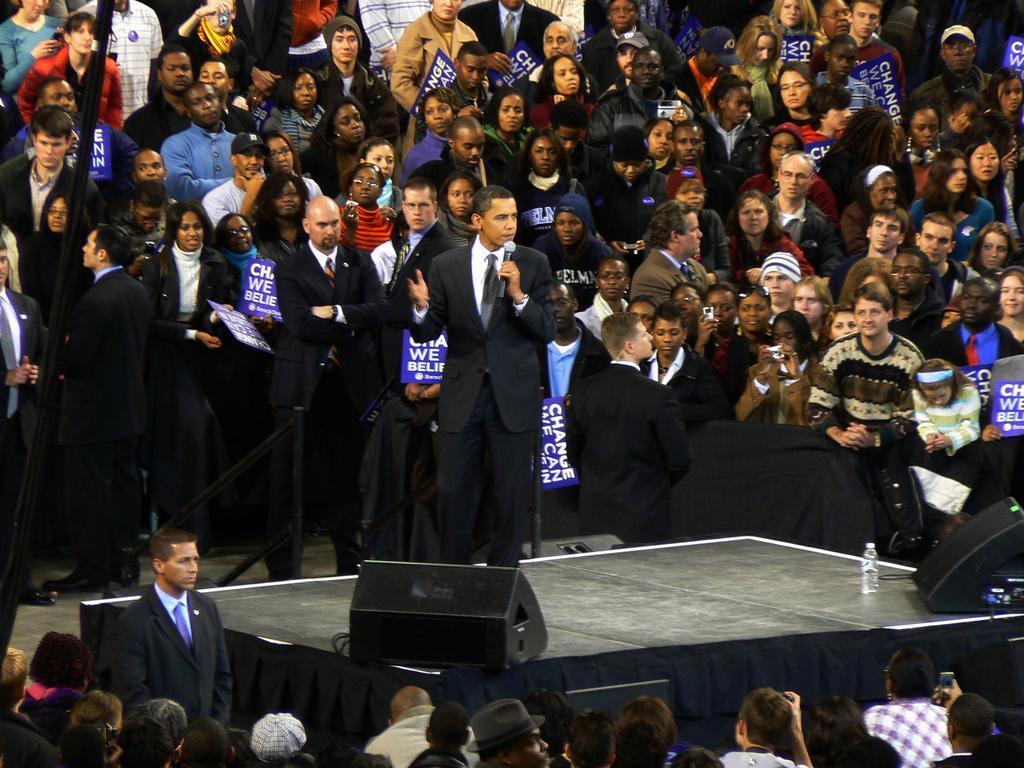Could you give a brief overview of what you see in this image? In this image we can see few people standing on the floor, some of them are holding boards and a person is standing on the stage and holding a mic and there are black colored object and a bottle on the stage. 